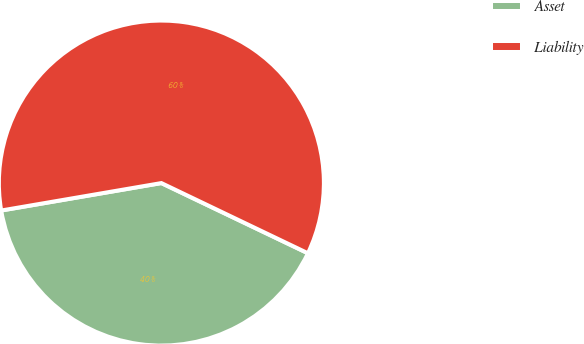Convert chart to OTSL. <chart><loc_0><loc_0><loc_500><loc_500><pie_chart><fcel>Asset<fcel>Liability<nl><fcel>40.19%<fcel>59.81%<nl></chart> 